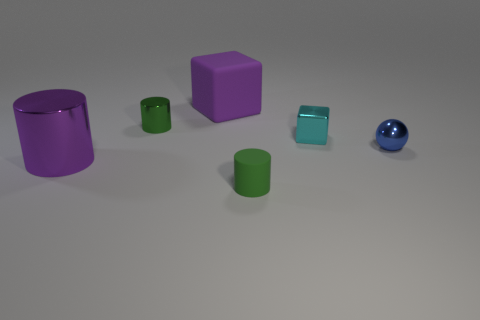Subtract all tiny green cylinders. How many cylinders are left? 1 Subtract all purple cylinders. How many cylinders are left? 2 Add 4 tiny spheres. How many objects exist? 10 Subtract all balls. How many objects are left? 5 Subtract all big green blocks. Subtract all big purple metallic objects. How many objects are left? 5 Add 4 tiny green rubber cylinders. How many tiny green rubber cylinders are left? 5 Add 6 balls. How many balls exist? 7 Subtract 1 blue spheres. How many objects are left? 5 Subtract 1 balls. How many balls are left? 0 Subtract all red balls. Subtract all red cylinders. How many balls are left? 1 